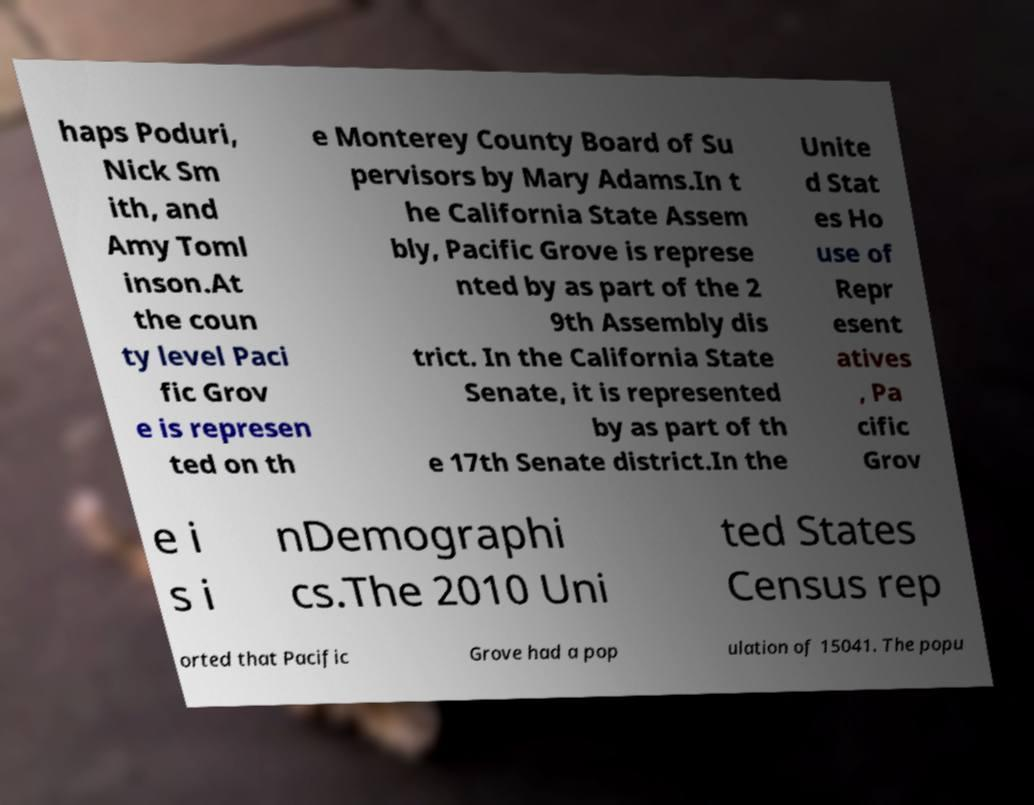There's text embedded in this image that I need extracted. Can you transcribe it verbatim? haps Poduri, Nick Sm ith, and Amy Toml inson.At the coun ty level Paci fic Grov e is represen ted on th e Monterey County Board of Su pervisors by Mary Adams.In t he California State Assem bly, Pacific Grove is represe nted by as part of the 2 9th Assembly dis trict. In the California State Senate, it is represented by as part of th e 17th Senate district.In the Unite d Stat es Ho use of Repr esent atives , Pa cific Grov e i s i nDemographi cs.The 2010 Uni ted States Census rep orted that Pacific Grove had a pop ulation of 15041. The popu 